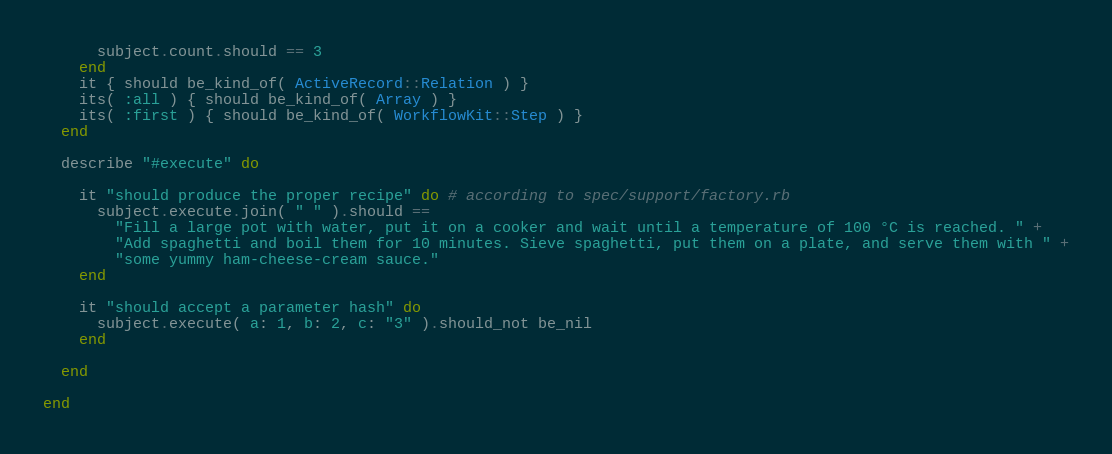<code> <loc_0><loc_0><loc_500><loc_500><_Ruby_>      subject.count.should == 3
    end
    it { should be_kind_of( ActiveRecord::Relation ) }
    its( :all ) { should be_kind_of( Array ) }
    its( :first ) { should be_kind_of( WorkflowKit::Step ) }
  end

  describe "#execute" do

    it "should produce the proper recipe" do # according to spec/support/factory.rb
      subject.execute.join( " " ).should ==
        "Fill a large pot with water, put it on a cooker and wait until a temperature of 100 °C is reached. " +
        "Add spaghetti and boil them for 10 minutes. Sieve spaghetti, put them on a plate, and serve them with " +
        "some yummy ham-cheese-cream sauce."
    end

    it "should accept a parameter hash" do
      subject.execute( a: 1, b: 2, c: "3" ).should_not be_nil
    end

  end

end

</code> 